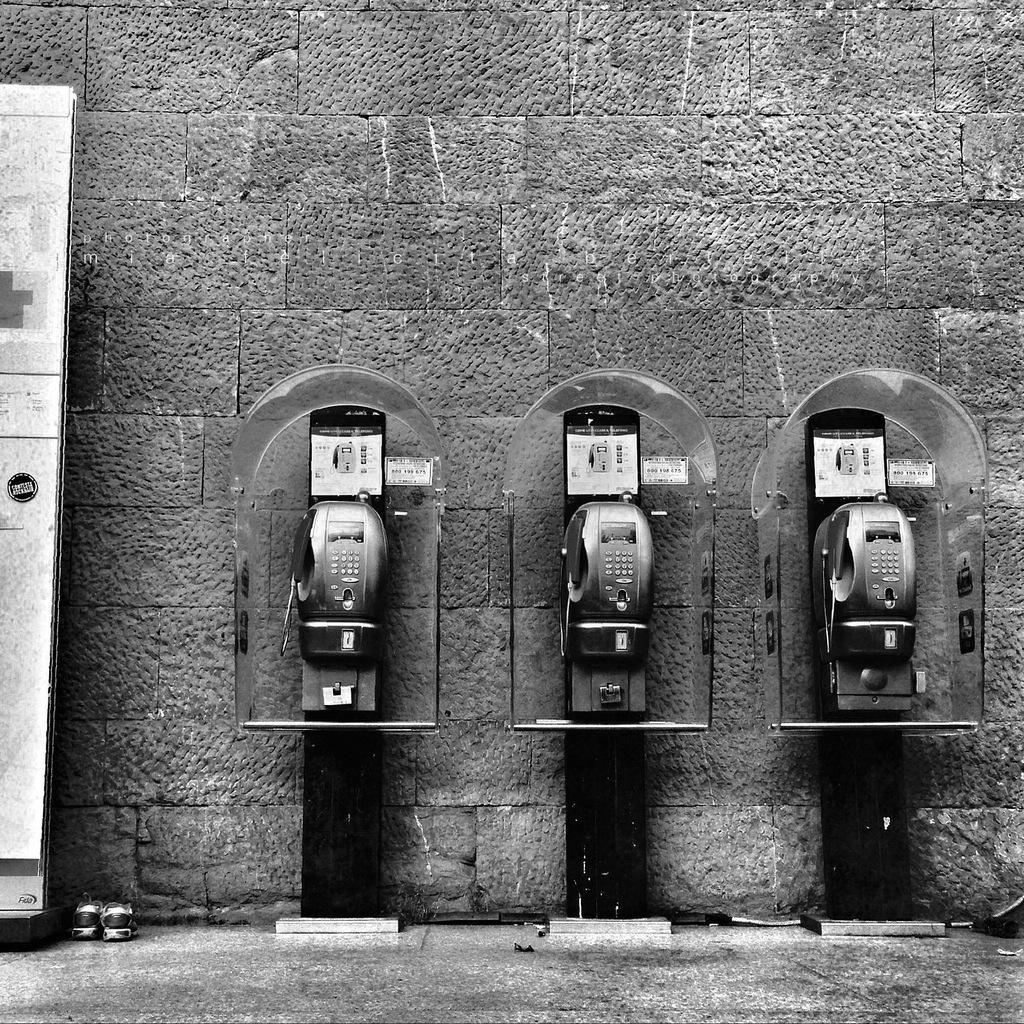Please provide a concise description of this image. In this image there are three telephone booths near the wall, there is a footwear and a stand. 